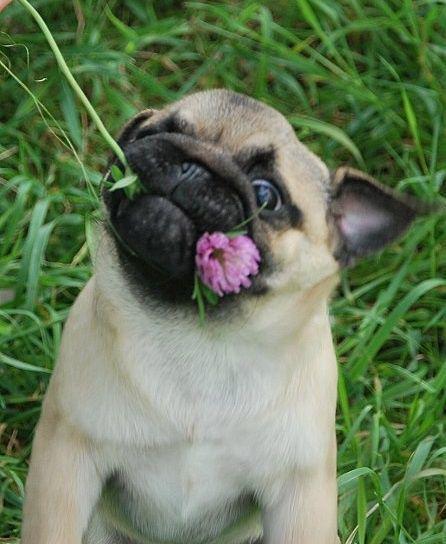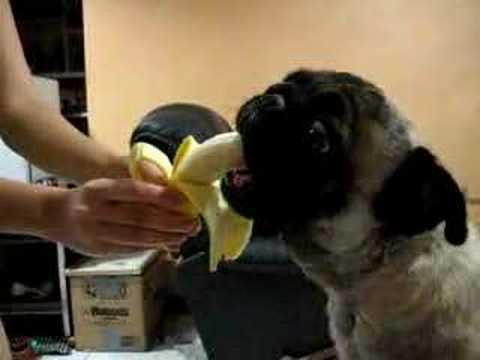The first image is the image on the left, the second image is the image on the right. Considering the images on both sides, is "All dogs shown are outdoors, and a hand is visible reaching from the right to offer a pug a banana in one image." valid? Answer yes or no. No. The first image is the image on the left, the second image is the image on the right. Given the left and right images, does the statement "The dog in the image on the right is being offered a banana." hold true? Answer yes or no. Yes. 